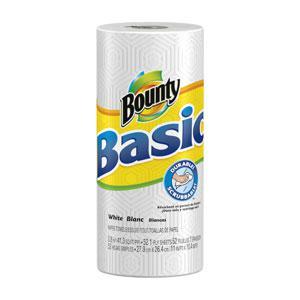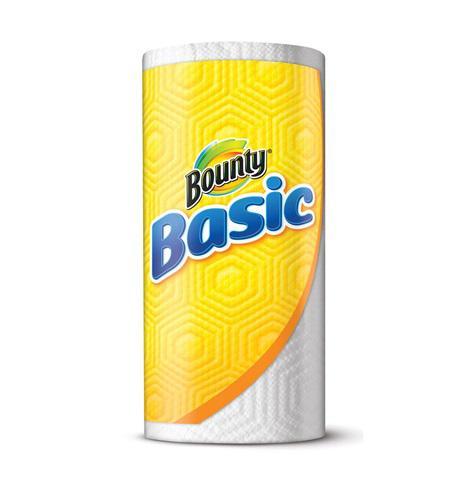The first image is the image on the left, the second image is the image on the right. Evaluate the accuracy of this statement regarding the images: "The paper towel packaging on the left depicts a man in a red flannel shirt, but the paper towel packaging on the right does not.". Is it true? Answer yes or no. No. The first image is the image on the left, the second image is the image on the right. Given the left and right images, does the statement "The left image contains at least six rolls of paper towels." hold true? Answer yes or no. No. 